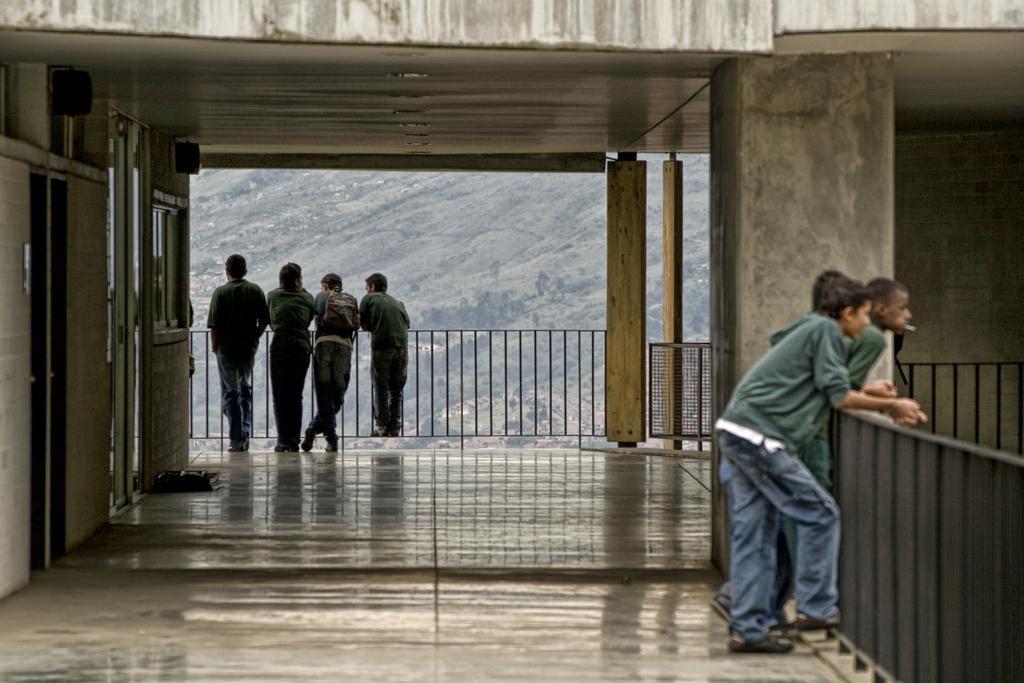Can you describe this image briefly? In this image we can see many people standing. There are railings and pillars. On the left side there are doors and windows. Also there are speakers. In the background there is hill. Also there are trees. 